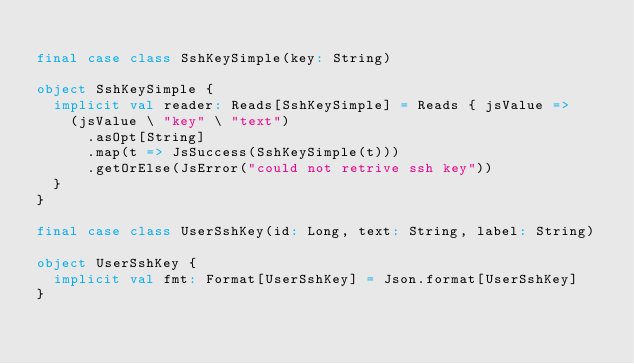<code> <loc_0><loc_0><loc_500><loc_500><_Scala_>
final case class SshKeySimple(key: String)

object SshKeySimple {
  implicit val reader: Reads[SshKeySimple] = Reads { jsValue =>
    (jsValue \ "key" \ "text")
      .asOpt[String]
      .map(t => JsSuccess(SshKeySimple(t)))
      .getOrElse(JsError("could not retrive ssh key"))
  }
}

final case class UserSshKey(id: Long, text: String, label: String)

object UserSshKey {
  implicit val fmt: Format[UserSshKey] = Json.format[UserSshKey]
}
</code> 